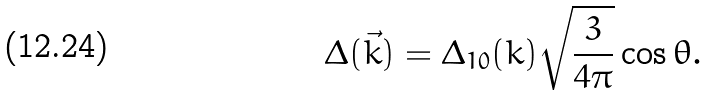Convert formula to latex. <formula><loc_0><loc_0><loc_500><loc_500>\Delta ( \vec { k } ) = \Delta _ { 1 0 } ( k ) \sqrt { \frac { 3 } { 4 \pi } } \cos \theta .</formula> 